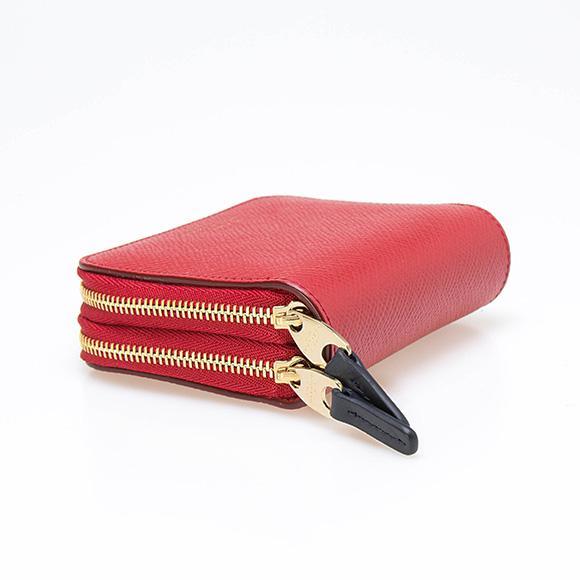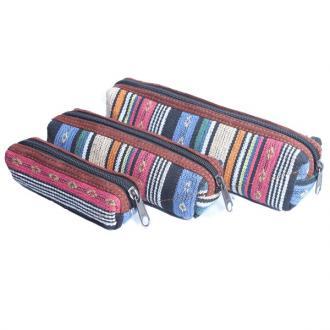The first image is the image on the left, the second image is the image on the right. Evaluate the accuracy of this statement regarding the images: "An image features a wooden pencil box that slides open, revealing several colored-lead pencils insides.". Is it true? Answer yes or no. No. The first image is the image on the left, the second image is the image on the right. Considering the images on both sides, is "The sliding top of a wooden pencil box is opened to display two levels of storage with an end space to store a sharpener, while a leather pencil case is shown in a second image." valid? Answer yes or no. No. 